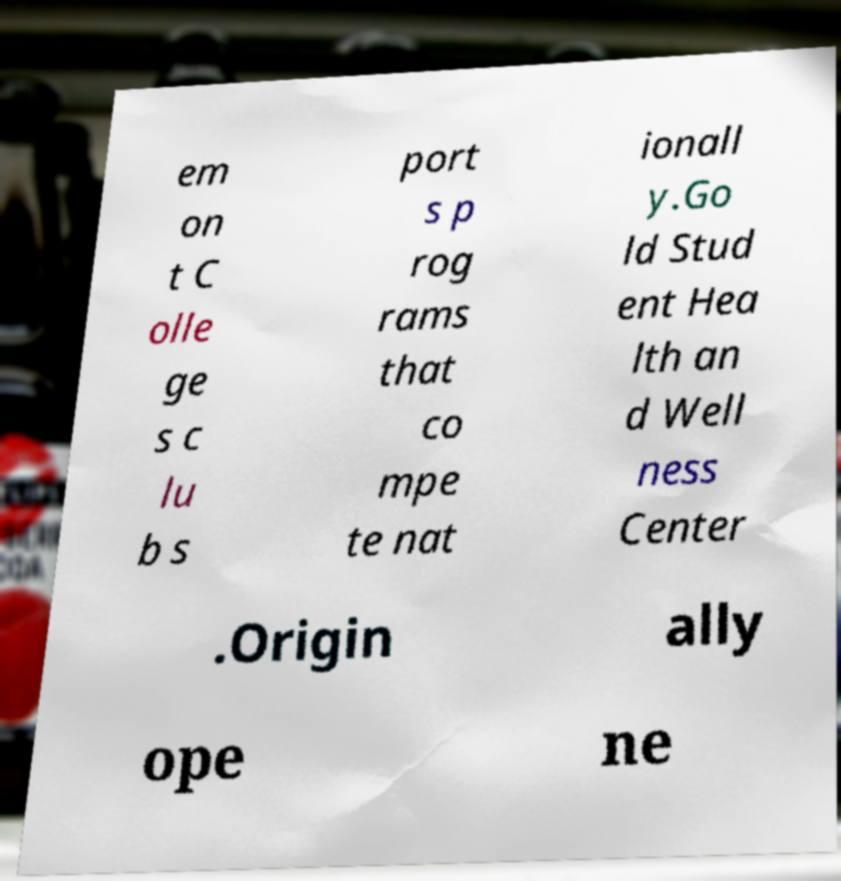Can you accurately transcribe the text from the provided image for me? em on t C olle ge s c lu b s port s p rog rams that co mpe te nat ionall y.Go ld Stud ent Hea lth an d Well ness Center .Origin ally ope ne 